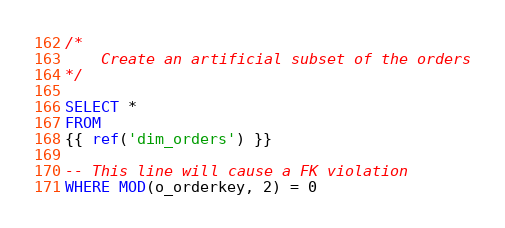<code> <loc_0><loc_0><loc_500><loc_500><_SQL_>
/*
    Create an artificial subset of the orders
*/

SELECT *
FROM
{{ ref('dim_orders') }}

-- This line will cause a FK violation
WHERE MOD(o_orderkey, 2) = 0
</code> 